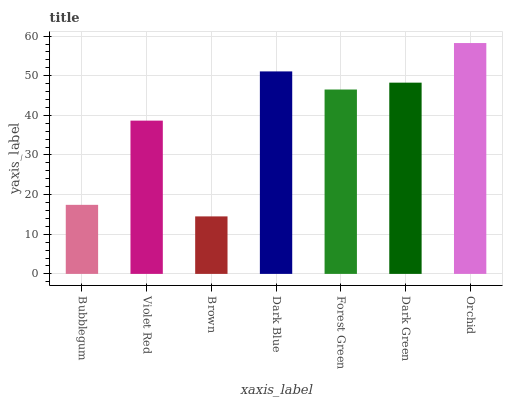Is Brown the minimum?
Answer yes or no. Yes. Is Orchid the maximum?
Answer yes or no. Yes. Is Violet Red the minimum?
Answer yes or no. No. Is Violet Red the maximum?
Answer yes or no. No. Is Violet Red greater than Bubblegum?
Answer yes or no. Yes. Is Bubblegum less than Violet Red?
Answer yes or no. Yes. Is Bubblegum greater than Violet Red?
Answer yes or no. No. Is Violet Red less than Bubblegum?
Answer yes or no. No. Is Forest Green the high median?
Answer yes or no. Yes. Is Forest Green the low median?
Answer yes or no. Yes. Is Orchid the high median?
Answer yes or no. No. Is Dark Green the low median?
Answer yes or no. No. 